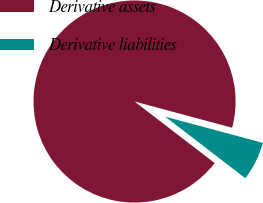Convert chart to OTSL. <chart><loc_0><loc_0><loc_500><loc_500><pie_chart><fcel>Derivative assets<fcel>Derivative liabilities<nl><fcel>93.75%<fcel>6.25%<nl></chart> 